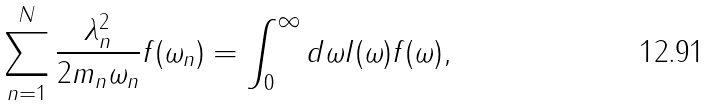Convert formula to latex. <formula><loc_0><loc_0><loc_500><loc_500>\sum _ { n = 1 } ^ { N } \frac { \lambda _ { n } ^ { 2 } } { 2 m _ { n } \omega _ { n } } f ( \omega _ { n } ) = \int _ { 0 } ^ { \infty } d \omega I ( \omega ) f ( \omega ) ,</formula> 